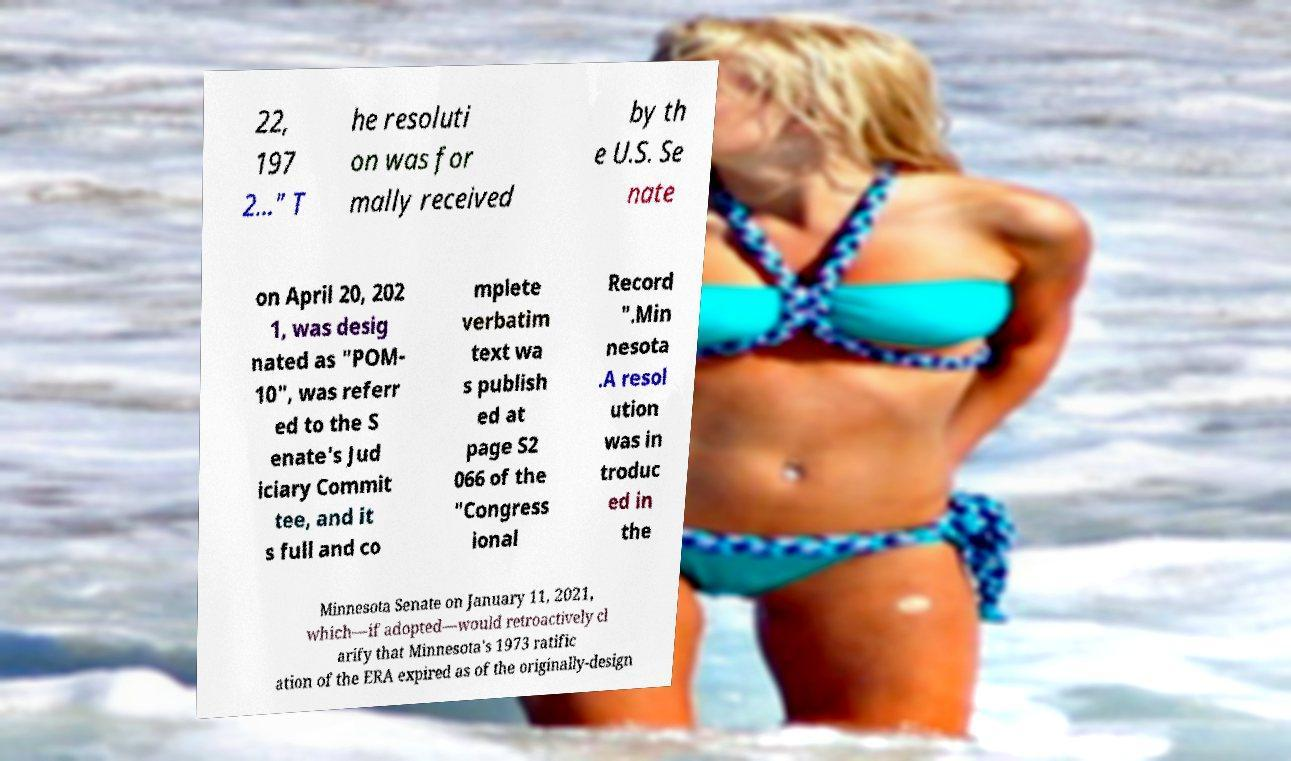What messages or text are displayed in this image? I need them in a readable, typed format. 22, 197 2..." T he resoluti on was for mally received by th e U.S. Se nate on April 20, 202 1, was desig nated as "POM- 10", was referr ed to the S enate's Jud iciary Commit tee, and it s full and co mplete verbatim text wa s publish ed at page S2 066 of the "Congress ional Record ".Min nesota .A resol ution was in troduc ed in the Minnesota Senate on January 11, 2021, which—if adopted—would retroactively cl arify that Minnesota's 1973 ratific ation of the ERA expired as of the originally-design 